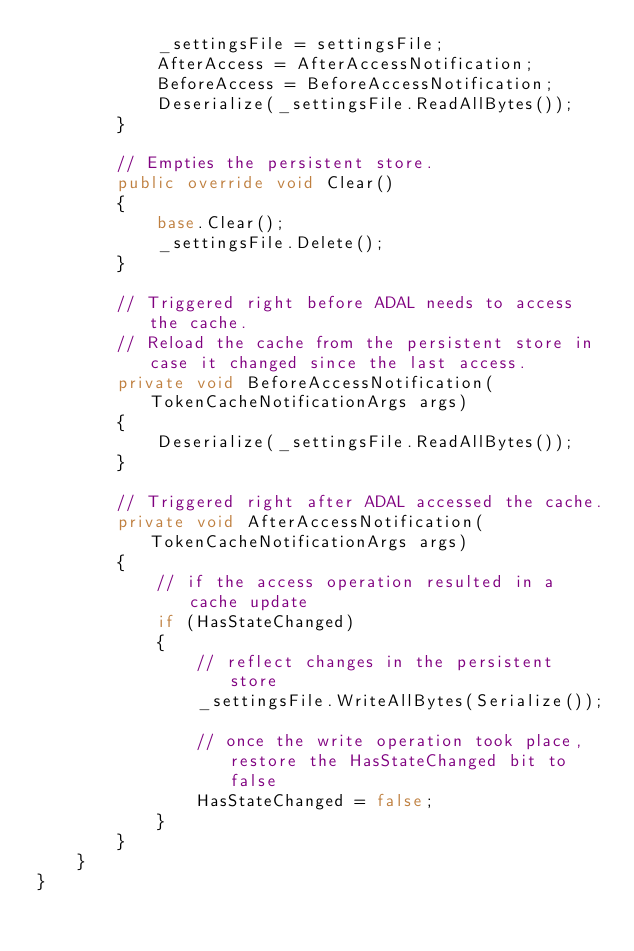<code> <loc_0><loc_0><loc_500><loc_500><_C#_>            _settingsFile = settingsFile;
            AfterAccess = AfterAccessNotification;
            BeforeAccess = BeforeAccessNotification;
            Deserialize(_settingsFile.ReadAllBytes());
        }

        // Empties the persistent store.
        public override void Clear()
        {
            base.Clear();
            _settingsFile.Delete();
        }

        // Triggered right before ADAL needs to access the cache.
        // Reload the cache from the persistent store in case it changed since the last access.
        private void BeforeAccessNotification(TokenCacheNotificationArgs args)
        {
            Deserialize(_settingsFile.ReadAllBytes());
        }

        // Triggered right after ADAL accessed the cache.
        private void AfterAccessNotification(TokenCacheNotificationArgs args)
        {
            // if the access operation resulted in a cache update
            if (HasStateChanged)
            {
                // reflect changes in the persistent store
                _settingsFile.WriteAllBytes(Serialize());

                // once the write operation took place, restore the HasStateChanged bit to false
                HasStateChanged = false;
            }
        }
    }
}
</code> 